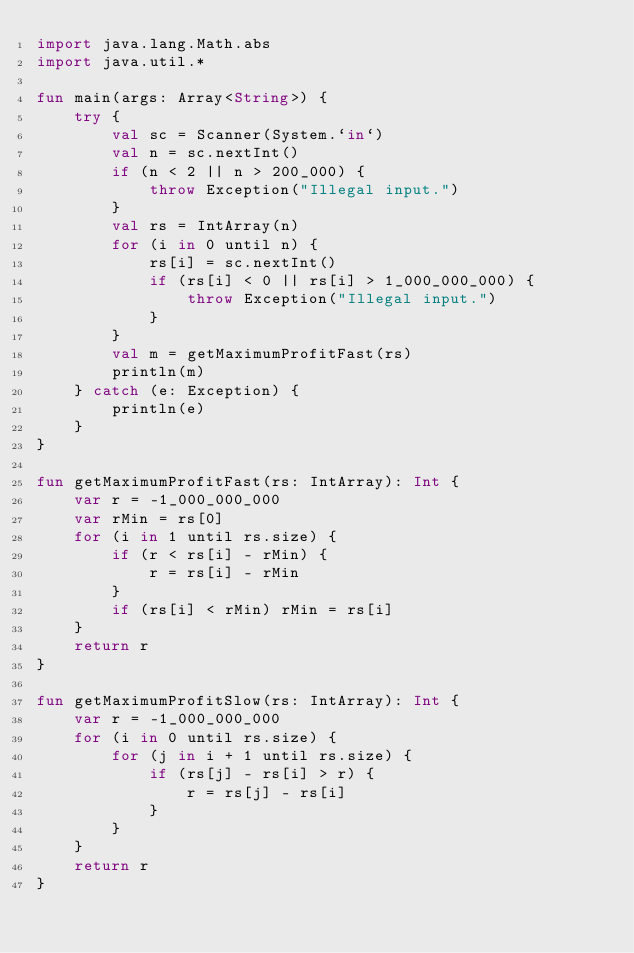Convert code to text. <code><loc_0><loc_0><loc_500><loc_500><_Kotlin_>import java.lang.Math.abs
import java.util.*

fun main(args: Array<String>) {
    try {
        val sc = Scanner(System.`in`)
        val n = sc.nextInt()
        if (n < 2 || n > 200_000) {
            throw Exception("Illegal input.")
        }
        val rs = IntArray(n)
        for (i in 0 until n) {
            rs[i] = sc.nextInt()
            if (rs[i] < 0 || rs[i] > 1_000_000_000) {
                throw Exception("Illegal input.")
            }
        }
        val m = getMaximumProfitFast(rs)
        println(m)
    } catch (e: Exception) {
        println(e)
    }
}

fun getMaximumProfitFast(rs: IntArray): Int {
    var r = -1_000_000_000
    var rMin = rs[0]
    for (i in 1 until rs.size) {
        if (r < rs[i] - rMin) {
            r = rs[i] - rMin
        }
        if (rs[i] < rMin) rMin = rs[i]
    }
    return r
}

fun getMaximumProfitSlow(rs: IntArray): Int {
    var r = -1_000_000_000
    for (i in 0 until rs.size) {
        for (j in i + 1 until rs.size) {
            if (rs[j] - rs[i] > r) {
                r = rs[j] - rs[i]
            }
        }
    }
    return r
}
</code> 